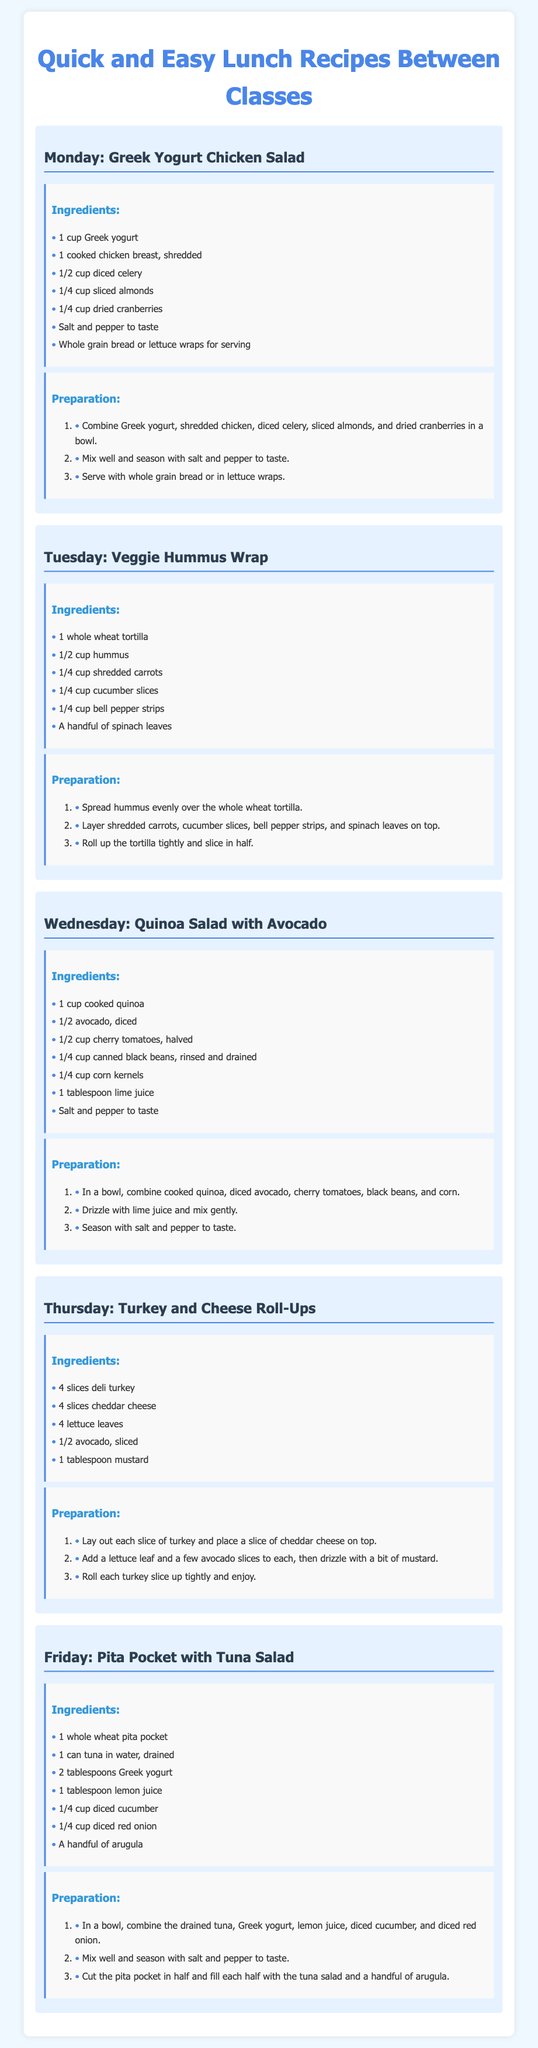What is the recipe for Monday? The recipe for Monday is Greek Yogurt Chicken Salad, as stated in the document.
Answer: Greek Yogurt Chicken Salad What is one ingredient in the Tuesday recipe? The Tuesday recipe is Veggie Hummus Wrap, which includes several ingredients like hummus, carrots, cucumber, etc.
Answer: Hummus How many slices of cheddar cheese are needed for the Thursday recipe? The Thursday recipe for Turkey and Cheese Roll-Ups specifies the use of 4 slices of cheddar cheese.
Answer: 4 slices What day features a salad with avocado? The document details a Quinoa Salad with Avocado on Wednesday.
Answer: Wednesday What is used for a dressing in the Friday recipe? The Friday recipe, Pita Pocket with Tuna Salad, uses lemon juice as one of its ingredients.
Answer: Lemon juice How many lettuce leaves are required for the Thursday recipe? The Thursday recipe indicates that 4 lettuce leaves are a necessary ingredient.
Answer: 4 Which recipe includes whole grain bread? The Monday recipe includes whole grain bread or lettuce wraps for serving.
Answer: Greek Yogurt Chicken Salad What is the main protein source in the Tuesday recipe? The Tuesday recipe does not have a defined protein source, but it mainly features vegetables with hummus.
Answer: Hummus How many steps are in the preparation for the Wednesday recipe? The preparation for the Wednesday recipe consists of 3 steps outlined in the document.
Answer: 3 steps 